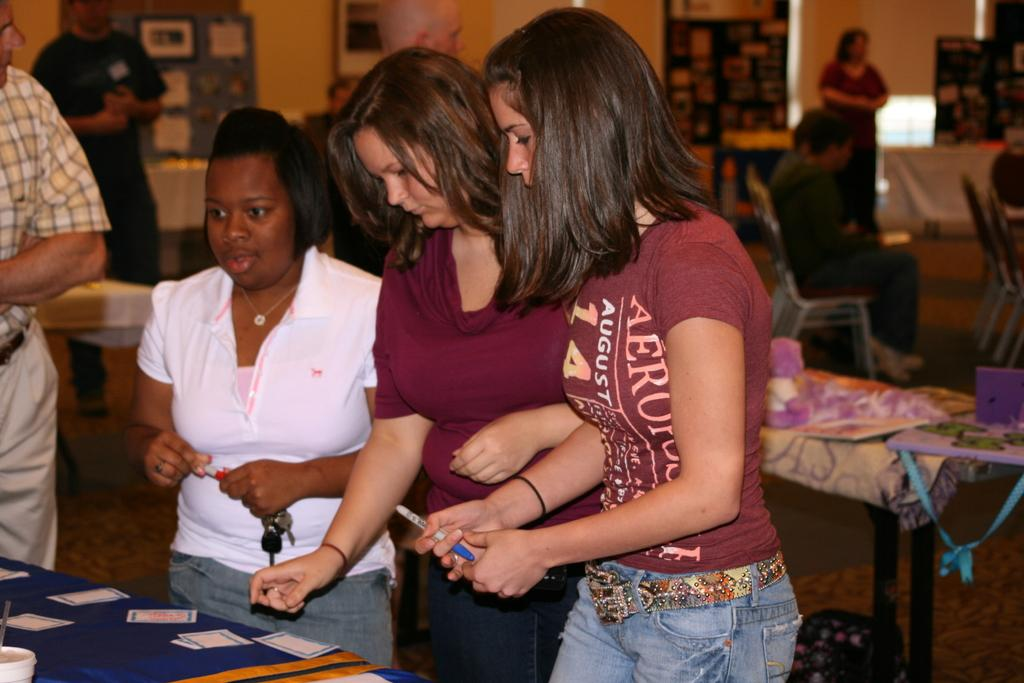What are the people in the image doing? There are persons standing and sitting on chairs in the image. What objects are present in the image that people might use? There are tables and chairs in the image, as well as a cup on the table. What is on the table besides the cup? Papers are present on the table. What can be seen on the floor in the image? The floor is visible in the image. What is in the background of the image? There is a wall in the background of the image. What type of feather can be seen falling from the ceiling in the image? There is no feather falling from the ceiling in the image. What emotion can be seen on the faces of the people in the image? The image does not show the faces of the people, so their emotions cannot be determined. 